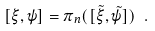<formula> <loc_0><loc_0><loc_500><loc_500>[ \xi , \psi ] = \pi _ { n } ( [ \tilde { \xi } , \tilde { \psi } ] ) \ .</formula> 